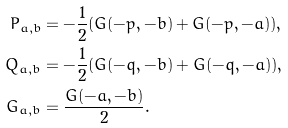Convert formula to latex. <formula><loc_0><loc_0><loc_500><loc_500>P _ { a , b } & = - \frac { 1 } { 2 } ( G ( - p , - b ) + G ( - p , - a ) ) , \\ Q _ { a , b } & = - \frac { 1 } { 2 } ( G ( - q , - b ) + G ( - q , - a ) ) , \\ G _ { a , b } & = \frac { G ( - a , - b ) } { 2 } .</formula> 